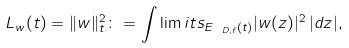Convert formula to latex. <formula><loc_0><loc_0><loc_500><loc_500>L _ { w } ( t ) = \| w \| ^ { 2 } _ { t } \colon = \int \lim i t s _ { E _ { \ D , f } ( t ) } | w ( z ) | ^ { 2 } \, | d z | ,</formula> 